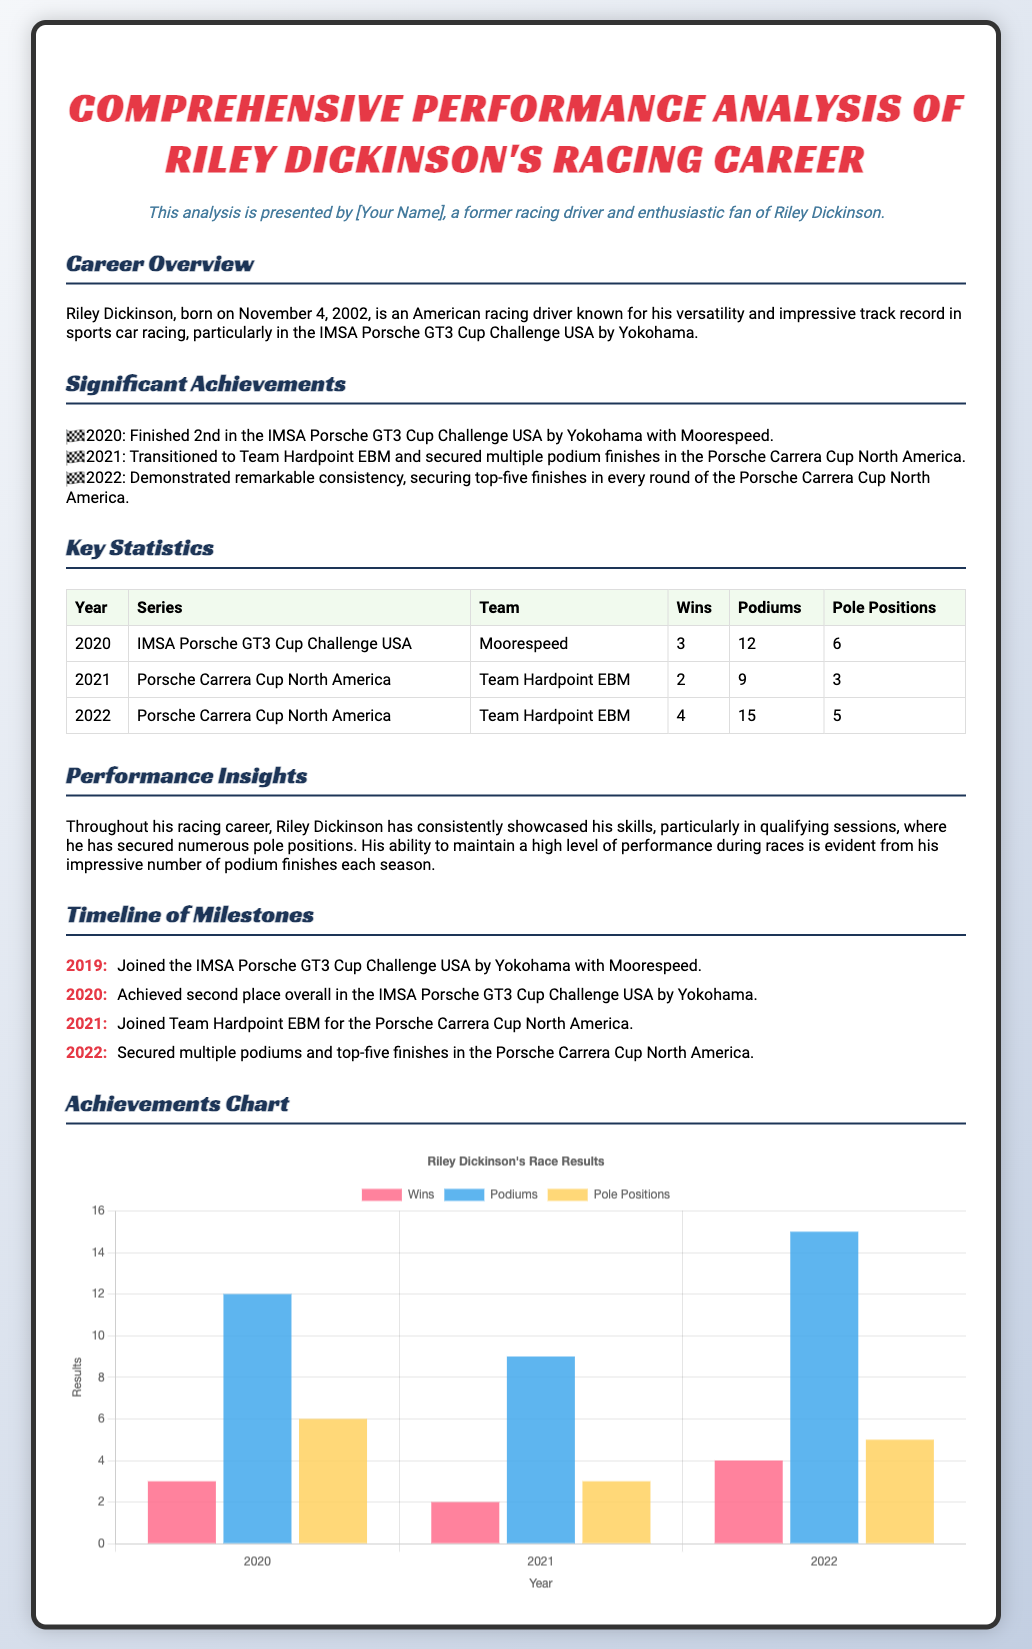What year was Riley Dickinson born? The document states that Riley Dickinson was born on November 4, 2002.
Answer: 2002 How many wins did Riley Dickinson achieve in 2020? The key statistics table indicates that he had 3 wins in 2020.
Answer: 3 What was Riley Dickinson's best series finish in 2020? According to the significant achievements section, he finished 2nd in the IMSA Porsche GT3 Cup Challenge USA by Yokohama in 2020.
Answer: 2nd How many podiums did Riley Dickinson secure in 2022? The key statistics table shows that he had 15 podium finishes in 2022.
Answer: 15 Which team did Riley Dickinson join in 2021? The timeline of milestones mentions that he joined Team Hardpoint EBM in 2021.
Answer: Team Hardpoint EBM In which racing series did Riley Dickinson race in 2021? The key statistics section indicates he raced in the Porsche Carrera Cup North America in 2021.
Answer: Porsche Carrera Cup North America What is the title of the achievements chart? The chart title provided in the document is "Riley Dickinson's Race Results."
Answer: Riley Dickinson's Race Results How many pole positions did he have in 2021? The key statistics table states that he had 3 pole positions in 2021.
Answer: 3 What color represents wins in the achievements chart? The document specifies that the background color for wins is 'rgba(255, 99, 132, 0.8)'.
Answer: rgba(255, 99, 132, 0.8) 